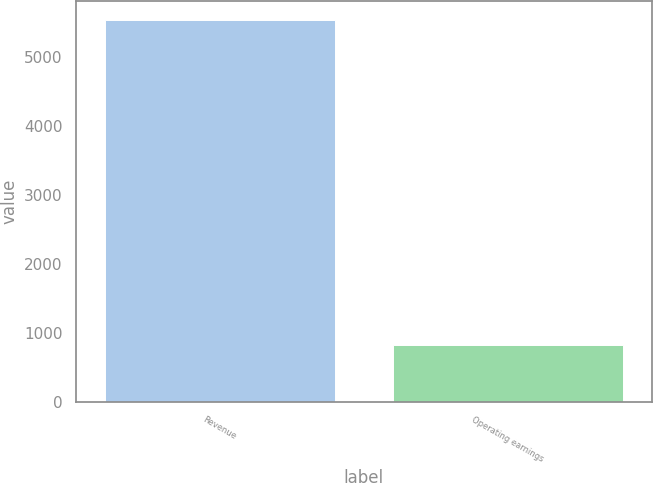<chart> <loc_0><loc_0><loc_500><loc_500><bar_chart><fcel>Revenue<fcel>Operating earnings<nl><fcel>5530<fcel>831<nl></chart> 